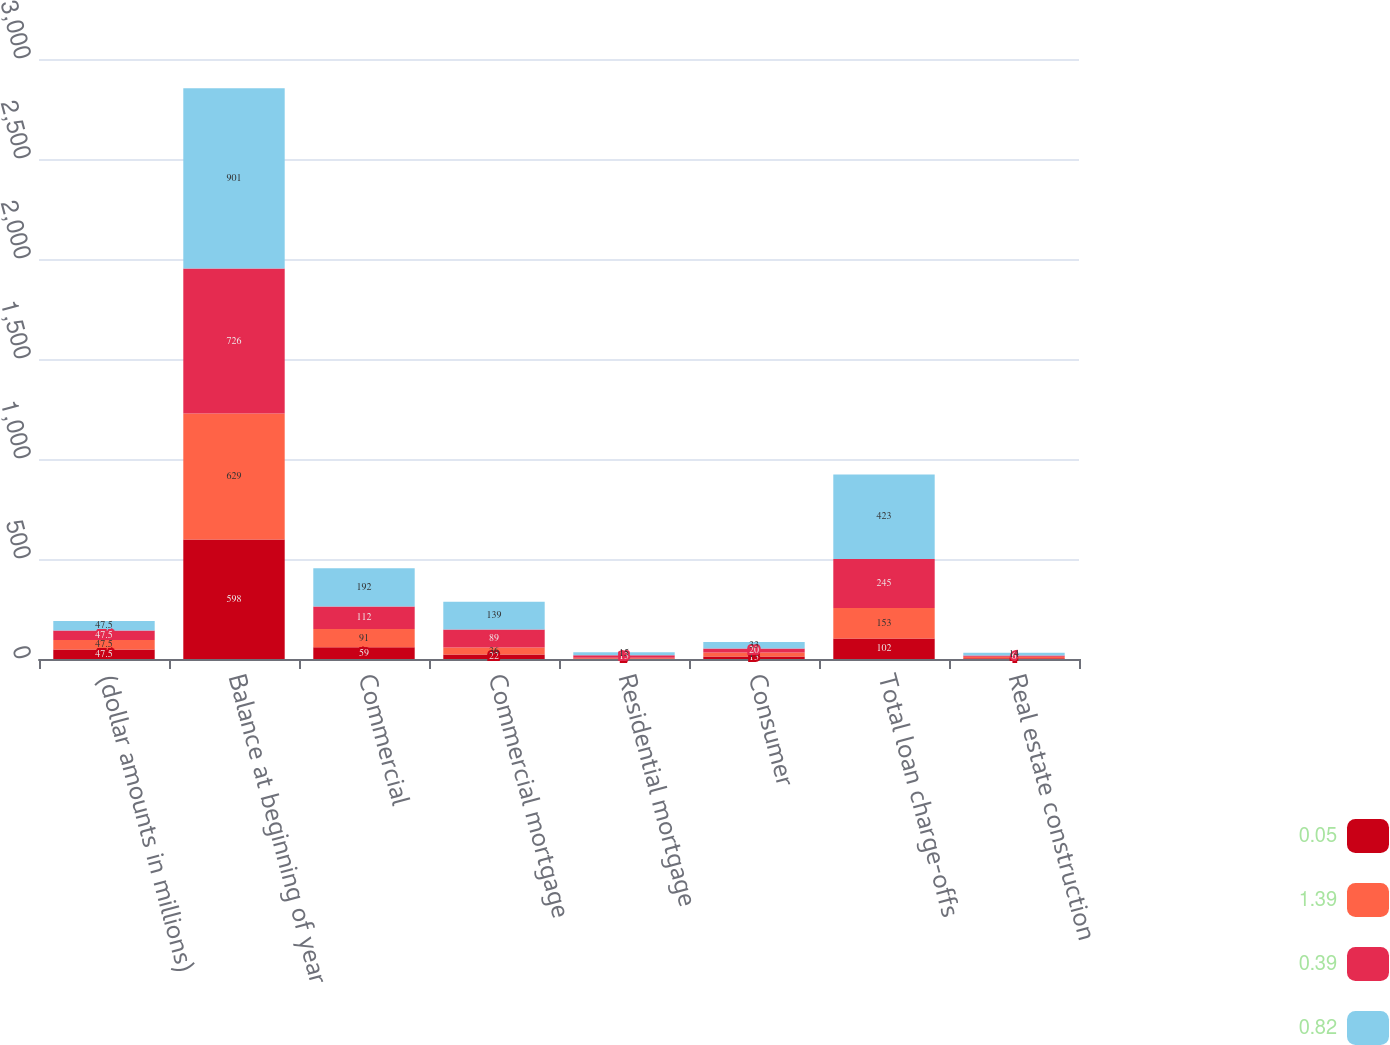<chart> <loc_0><loc_0><loc_500><loc_500><stacked_bar_chart><ecel><fcel>(dollar amounts in millions)<fcel>Balance at beginning of year<fcel>Commercial<fcel>Commercial mortgage<fcel>Residential mortgage<fcel>Consumer<fcel>Total loan charge-offs<fcel>Real estate construction<nl><fcel>0.05<fcel>47.5<fcel>598<fcel>59<fcel>22<fcel>2<fcel>13<fcel>102<fcel>4<nl><fcel>1.39<fcel>47.5<fcel>629<fcel>91<fcel>36<fcel>4<fcel>19<fcel>153<fcel>7<nl><fcel>0.39<fcel>47.5<fcel>726<fcel>112<fcel>89<fcel>13<fcel>20<fcel>245<fcel>6<nl><fcel>0.82<fcel>47.5<fcel>901<fcel>192<fcel>139<fcel>15<fcel>33<fcel>423<fcel>14<nl></chart> 